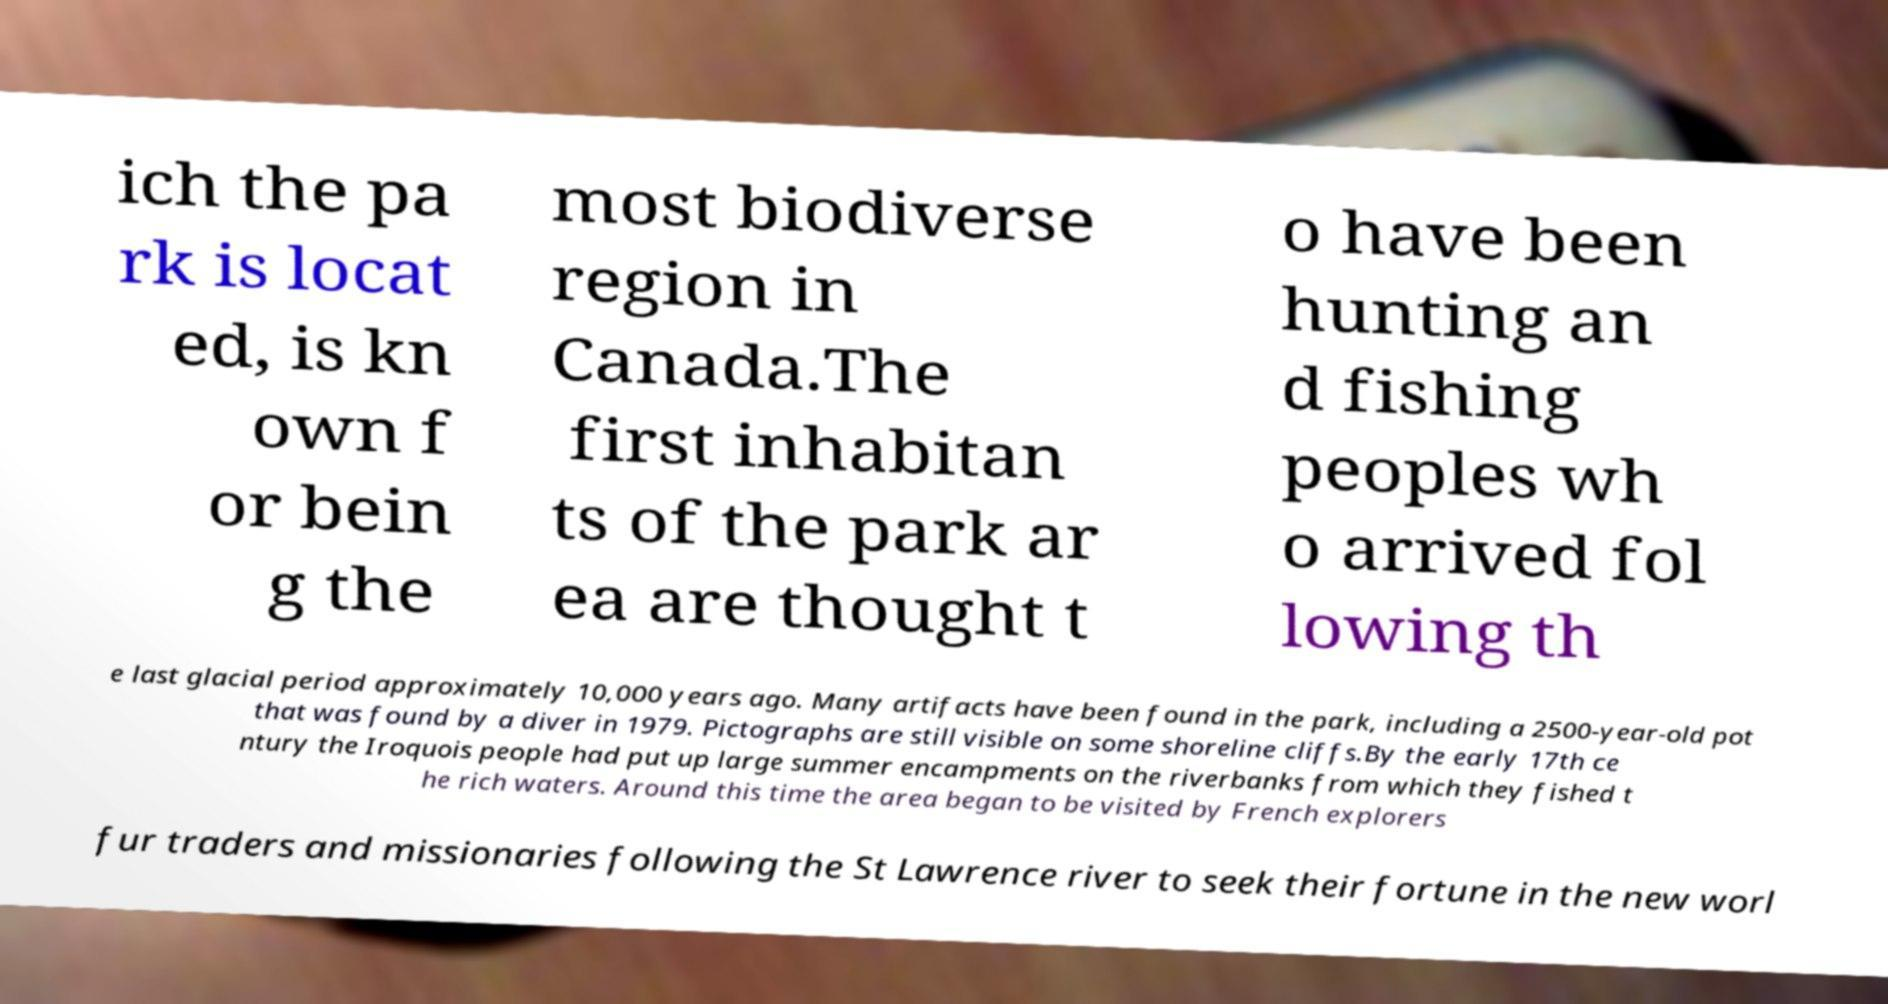I need the written content from this picture converted into text. Can you do that? ich the pa rk is locat ed, is kn own f or bein g the most biodiverse region in Canada.The first inhabitan ts of the park ar ea are thought t o have been hunting an d fishing peoples wh o arrived fol lowing th e last glacial period approximately 10,000 years ago. Many artifacts have been found in the park, including a 2500-year-old pot that was found by a diver in 1979. Pictographs are still visible on some shoreline cliffs.By the early 17th ce ntury the Iroquois people had put up large summer encampments on the riverbanks from which they fished t he rich waters. Around this time the area began to be visited by French explorers fur traders and missionaries following the St Lawrence river to seek their fortune in the new worl 